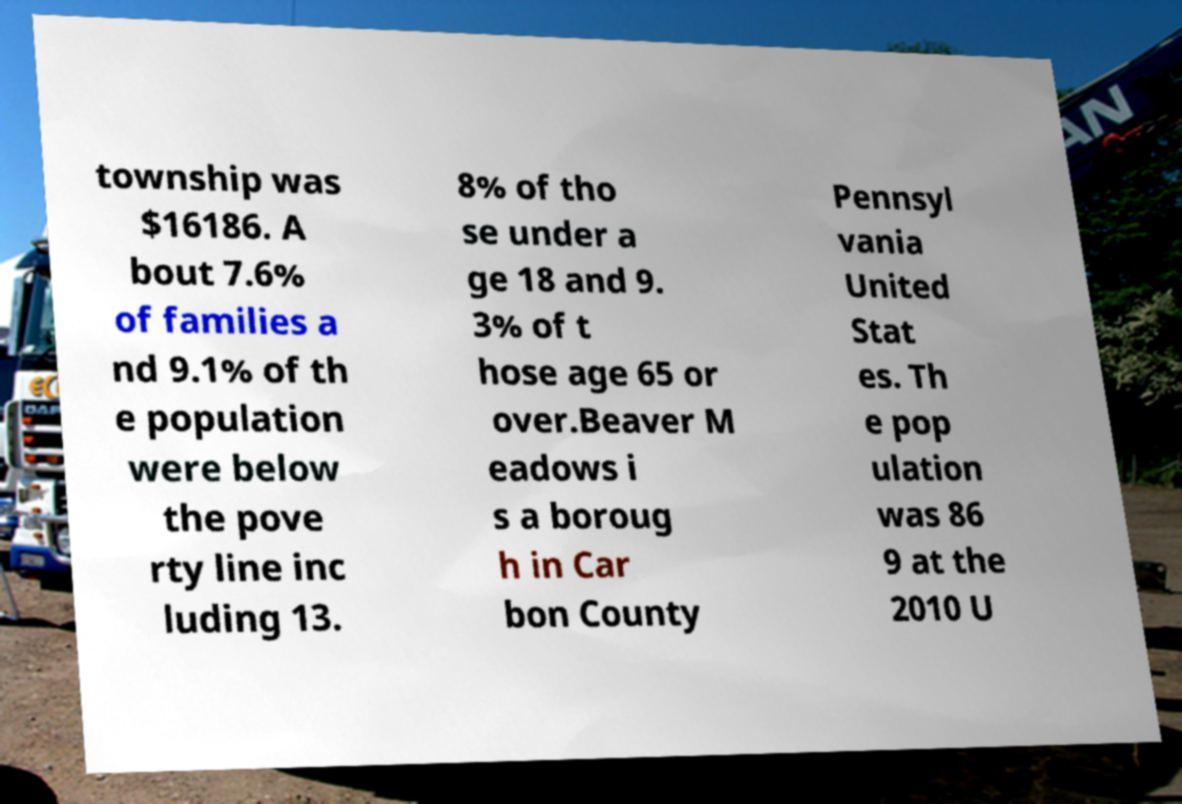I need the written content from this picture converted into text. Can you do that? township was $16186. A bout 7.6% of families a nd 9.1% of th e population were below the pove rty line inc luding 13. 8% of tho se under a ge 18 and 9. 3% of t hose age 65 or over.Beaver M eadows i s a boroug h in Car bon County Pennsyl vania United Stat es. Th e pop ulation was 86 9 at the 2010 U 